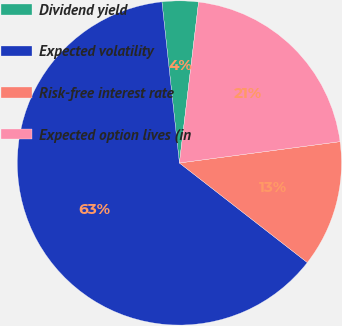<chart> <loc_0><loc_0><loc_500><loc_500><pie_chart><fcel>Dividend yield<fcel>Expected volatility<fcel>Risk-free interest rate<fcel>Expected option lives (in<nl><fcel>3.61%<fcel>62.75%<fcel>12.63%<fcel>21.01%<nl></chart> 